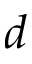Convert formula to latex. <formula><loc_0><loc_0><loc_500><loc_500>d</formula> 